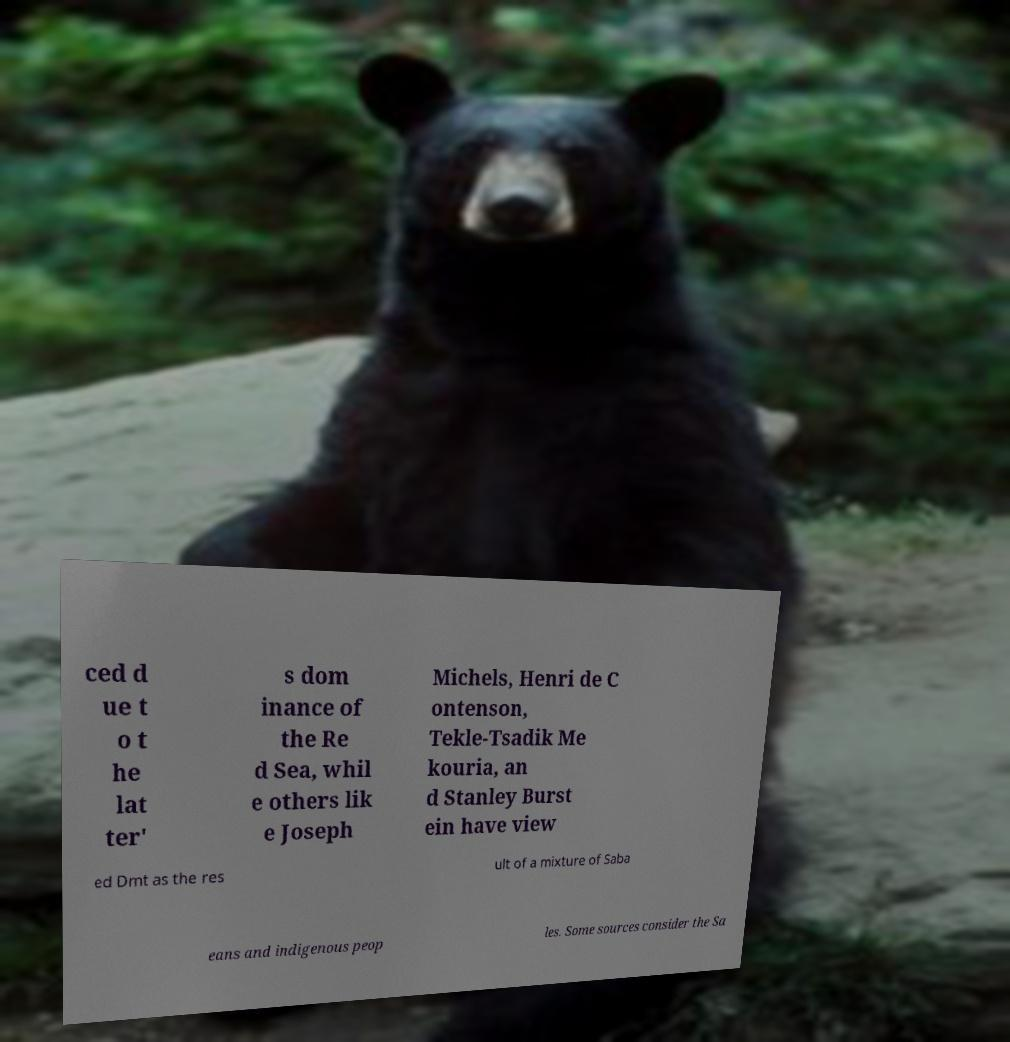Can you read and provide the text displayed in the image?This photo seems to have some interesting text. Can you extract and type it out for me? ced d ue t o t he lat ter' s dom inance of the Re d Sea, whil e others lik e Joseph Michels, Henri de C ontenson, Tekle-Tsadik Me kouria, an d Stanley Burst ein have view ed Dmt as the res ult of a mixture of Saba eans and indigenous peop les. Some sources consider the Sa 